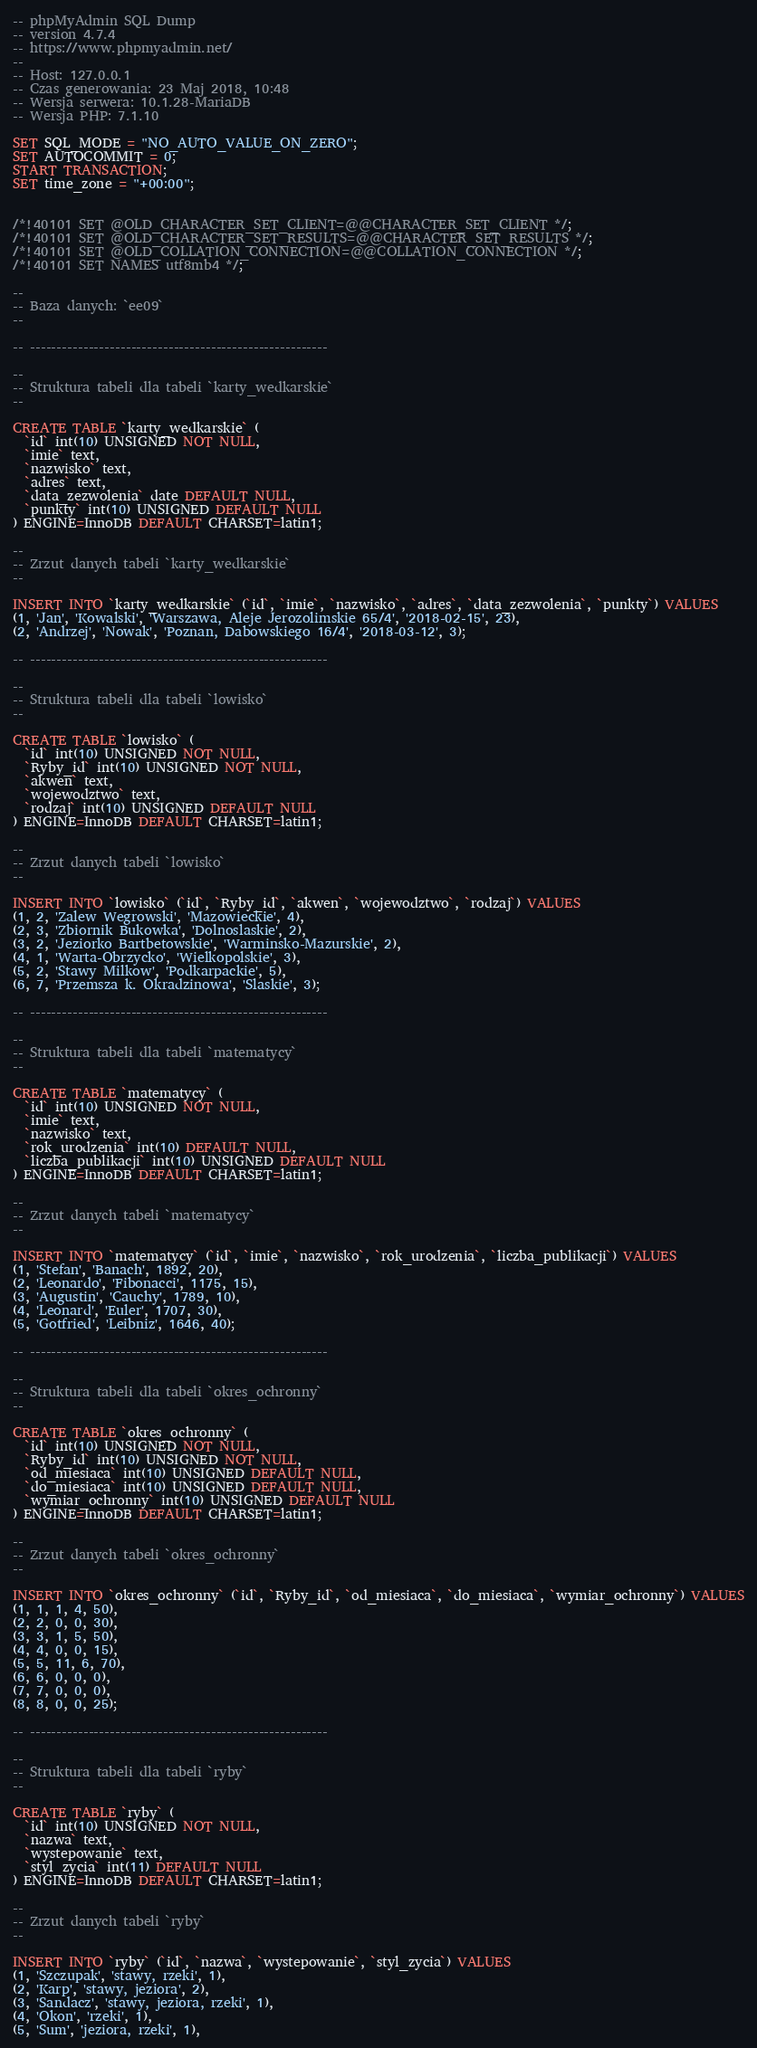<code> <loc_0><loc_0><loc_500><loc_500><_SQL_>-- phpMyAdmin SQL Dump
-- version 4.7.4
-- https://www.phpmyadmin.net/
--
-- Host: 127.0.0.1
-- Czas generowania: 23 Maj 2018, 10:48
-- Wersja serwera: 10.1.28-MariaDB
-- Wersja PHP: 7.1.10

SET SQL_MODE = "NO_AUTO_VALUE_ON_ZERO";
SET AUTOCOMMIT = 0;
START TRANSACTION;
SET time_zone = "+00:00";


/*!40101 SET @OLD_CHARACTER_SET_CLIENT=@@CHARACTER_SET_CLIENT */;
/*!40101 SET @OLD_CHARACTER_SET_RESULTS=@@CHARACTER_SET_RESULTS */;
/*!40101 SET @OLD_COLLATION_CONNECTION=@@COLLATION_CONNECTION */;
/*!40101 SET NAMES utf8mb4 */;

--
-- Baza danych: `ee09`
--

-- --------------------------------------------------------

--
-- Struktura tabeli dla tabeli `karty_wedkarskie`
--

CREATE TABLE `karty_wedkarskie` (
  `id` int(10) UNSIGNED NOT NULL,
  `imie` text,
  `nazwisko` text,
  `adres` text,
  `data_zezwolenia` date DEFAULT NULL,
  `punkty` int(10) UNSIGNED DEFAULT NULL
) ENGINE=InnoDB DEFAULT CHARSET=latin1;

--
-- Zrzut danych tabeli `karty_wedkarskie`
--

INSERT INTO `karty_wedkarskie` (`id`, `imie`, `nazwisko`, `adres`, `data_zezwolenia`, `punkty`) VALUES
(1, 'Jan', 'Kowalski', 'Warszawa, Aleje Jerozolimskie 65/4', '2018-02-15', 23),
(2, 'Andrzej', 'Nowak', 'Poznan, Dabowskiego 16/4', '2018-03-12', 3);

-- --------------------------------------------------------

--
-- Struktura tabeli dla tabeli `lowisko`
--

CREATE TABLE `lowisko` (
  `id` int(10) UNSIGNED NOT NULL,
  `Ryby_id` int(10) UNSIGNED NOT NULL,
  `akwen` text,
  `wojewodztwo` text,
  `rodzaj` int(10) UNSIGNED DEFAULT NULL
) ENGINE=InnoDB DEFAULT CHARSET=latin1;

--
-- Zrzut danych tabeli `lowisko`
--

INSERT INTO `lowisko` (`id`, `Ryby_id`, `akwen`, `wojewodztwo`, `rodzaj`) VALUES
(1, 2, 'Zalew Wegrowski', 'Mazowieckie', 4),
(2, 3, 'Zbiornik Bukowka', 'Dolnoslaskie', 2),
(3, 2, 'Jeziorko Bartbetowskie', 'Warminsko-Mazurskie', 2),
(4, 1, 'Warta-Obrzycko', 'Wielkopolskie', 3),
(5, 2, 'Stawy Milkow', 'Podkarpackie', 5),
(6, 7, 'Przemsza k. Okradzinowa', 'Slaskie', 3);

-- --------------------------------------------------------

--
-- Struktura tabeli dla tabeli `matematycy`
--

CREATE TABLE `matematycy` (
  `id` int(10) UNSIGNED NOT NULL,
  `imie` text,
  `nazwisko` text,
  `rok_urodzenia` int(10) DEFAULT NULL,
  `liczba_publikacji` int(10) UNSIGNED DEFAULT NULL
) ENGINE=InnoDB DEFAULT CHARSET=latin1;

--
-- Zrzut danych tabeli `matematycy`
--

INSERT INTO `matematycy` (`id`, `imie`, `nazwisko`, `rok_urodzenia`, `liczba_publikacji`) VALUES
(1, 'Stefan', 'Banach', 1892, 20),
(2, 'Leonardo', 'Fibonacci', 1175, 15),
(3, 'Augustin', 'Cauchy', 1789, 10),
(4, 'Leonard', 'Euler', 1707, 30),
(5, 'Gotfried', 'Leibniz', 1646, 40);

-- --------------------------------------------------------

--
-- Struktura tabeli dla tabeli `okres_ochronny`
--

CREATE TABLE `okres_ochronny` (
  `id` int(10) UNSIGNED NOT NULL,
  `Ryby_id` int(10) UNSIGNED NOT NULL,
  `od_miesiaca` int(10) UNSIGNED DEFAULT NULL,
  `do_miesiaca` int(10) UNSIGNED DEFAULT NULL,
  `wymiar_ochronny` int(10) UNSIGNED DEFAULT NULL
) ENGINE=InnoDB DEFAULT CHARSET=latin1;

--
-- Zrzut danych tabeli `okres_ochronny`
--

INSERT INTO `okres_ochronny` (`id`, `Ryby_id`, `od_miesiaca`, `do_miesiaca`, `wymiar_ochronny`) VALUES
(1, 1, 1, 4, 50),
(2, 2, 0, 0, 30),
(3, 3, 1, 5, 50),
(4, 4, 0, 0, 15),
(5, 5, 11, 6, 70),
(6, 6, 0, 0, 0),
(7, 7, 0, 0, 0),
(8, 8, 0, 0, 25);

-- --------------------------------------------------------

--
-- Struktura tabeli dla tabeli `ryby`
--

CREATE TABLE `ryby` (
  `id` int(10) UNSIGNED NOT NULL,
  `nazwa` text,
  `wystepowanie` text,
  `styl_zycia` int(11) DEFAULT NULL
) ENGINE=InnoDB DEFAULT CHARSET=latin1;

--
-- Zrzut danych tabeli `ryby`
--

INSERT INTO `ryby` (`id`, `nazwa`, `wystepowanie`, `styl_zycia`) VALUES
(1, 'Szczupak', 'stawy, rzeki', 1),
(2, 'Karp', 'stawy, jeziora', 2),
(3, 'Sandacz', 'stawy, jeziora, rzeki', 1),
(4, 'Okon', 'rzeki', 1),
(5, 'Sum', 'jeziora, rzeki', 1),</code> 